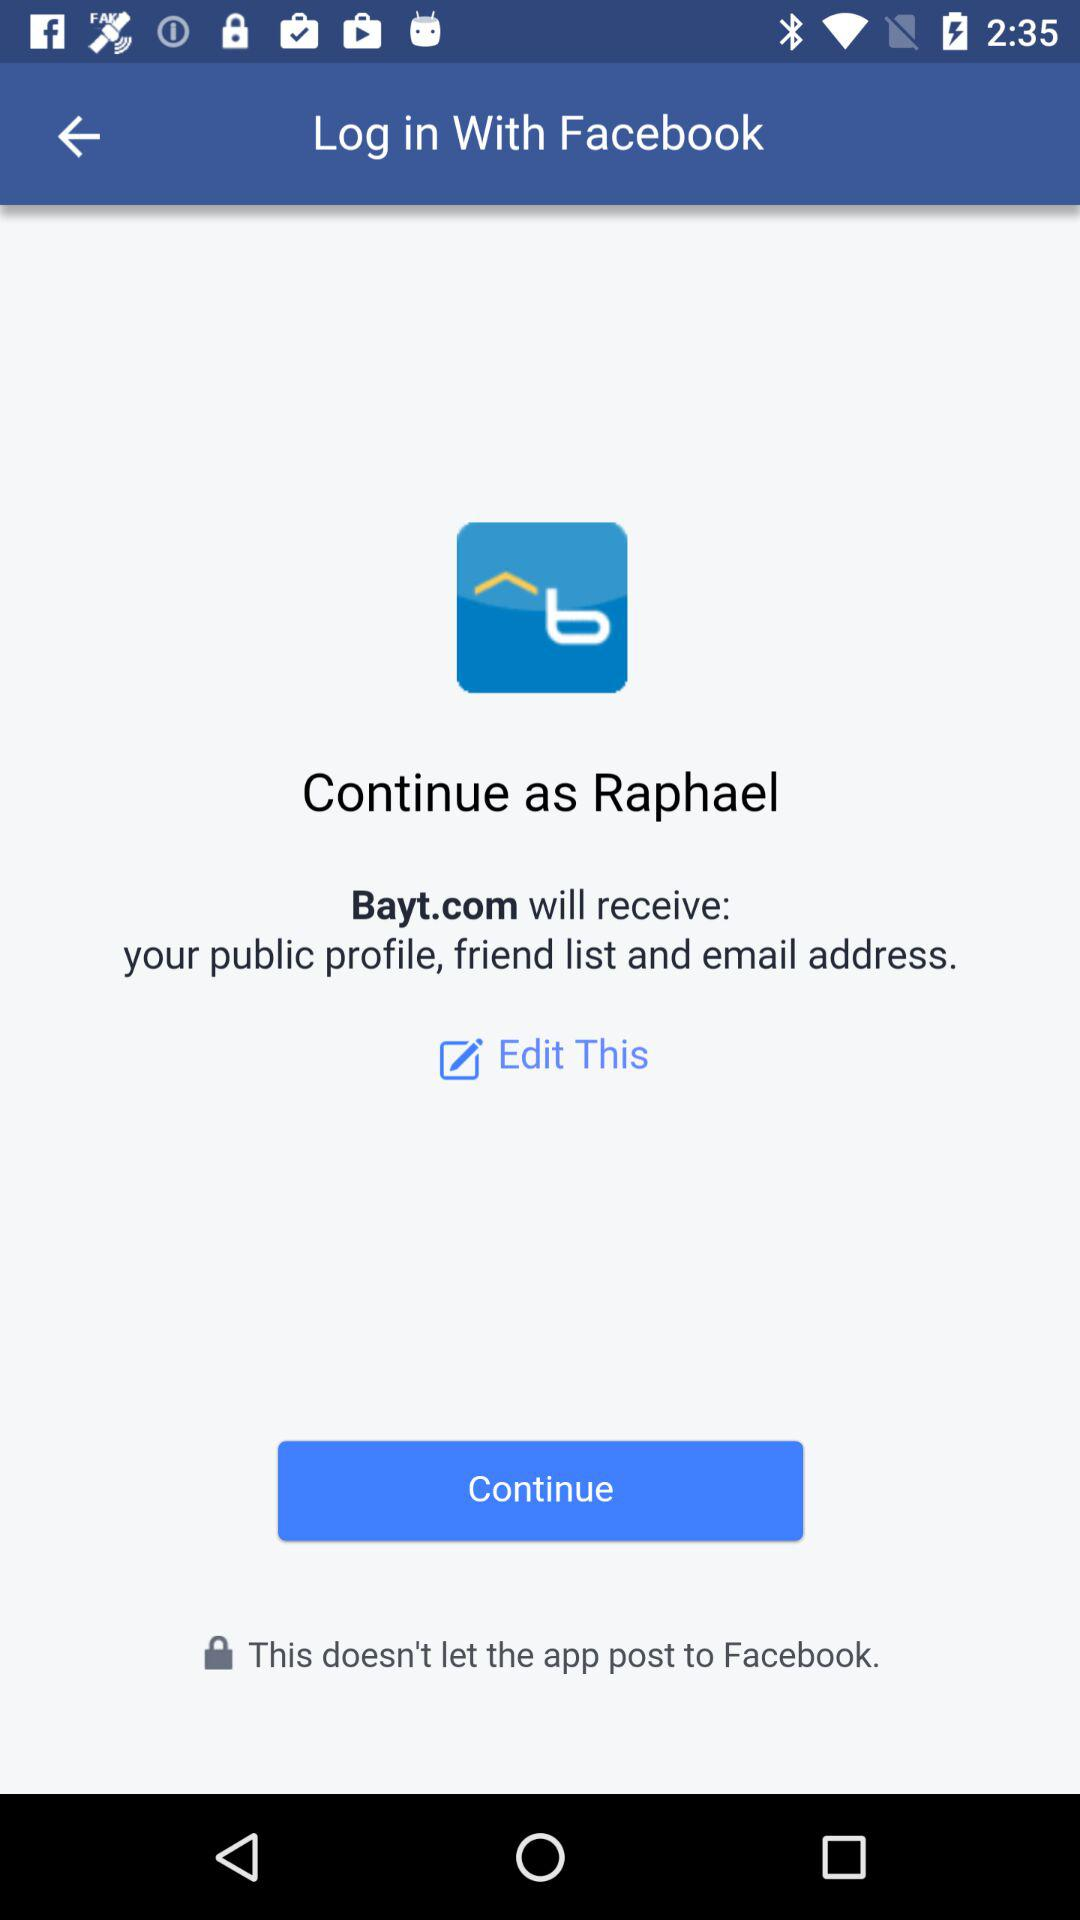What website will receive the public profile, friend list and email address? The website that will receive the public profile, friend list and email address is Bayt.com. 